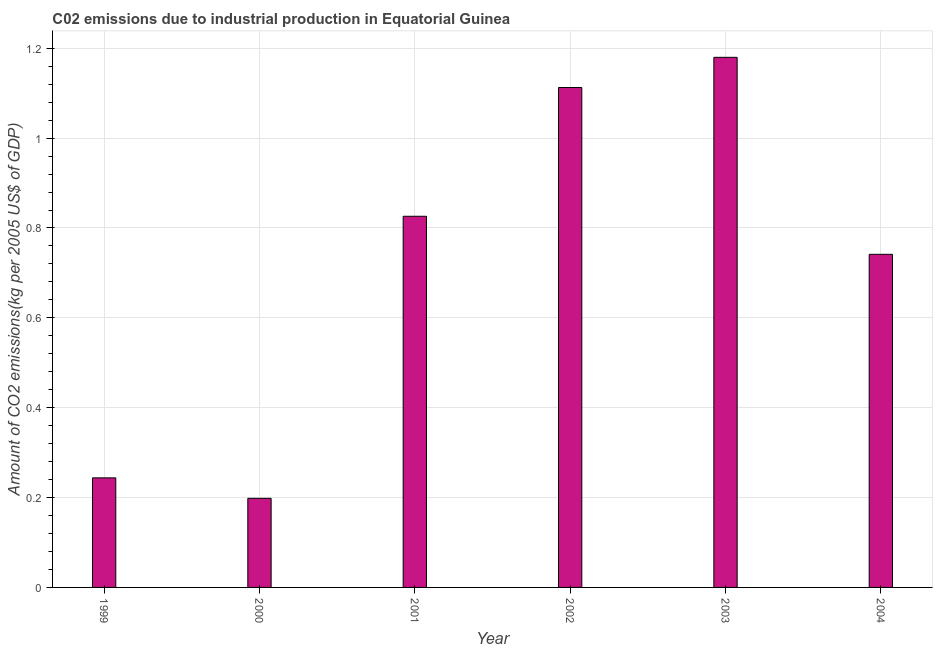Does the graph contain any zero values?
Your answer should be compact. No. What is the title of the graph?
Provide a succinct answer. C02 emissions due to industrial production in Equatorial Guinea. What is the label or title of the X-axis?
Ensure brevity in your answer.  Year. What is the label or title of the Y-axis?
Give a very brief answer. Amount of CO2 emissions(kg per 2005 US$ of GDP). What is the amount of co2 emissions in 2003?
Give a very brief answer. 1.18. Across all years, what is the maximum amount of co2 emissions?
Offer a very short reply. 1.18. Across all years, what is the minimum amount of co2 emissions?
Your answer should be compact. 0.2. In which year was the amount of co2 emissions maximum?
Your response must be concise. 2003. What is the sum of the amount of co2 emissions?
Your answer should be very brief. 4.3. What is the difference between the amount of co2 emissions in 1999 and 2001?
Make the answer very short. -0.58. What is the average amount of co2 emissions per year?
Ensure brevity in your answer.  0.72. What is the median amount of co2 emissions?
Provide a short and direct response. 0.78. What is the ratio of the amount of co2 emissions in 1999 to that in 2002?
Keep it short and to the point. 0.22. Is the amount of co2 emissions in 1999 less than that in 2002?
Provide a succinct answer. Yes. Is the difference between the amount of co2 emissions in 2001 and 2003 greater than the difference between any two years?
Keep it short and to the point. No. What is the difference between the highest and the second highest amount of co2 emissions?
Offer a terse response. 0.07. Is the sum of the amount of co2 emissions in 1999 and 2003 greater than the maximum amount of co2 emissions across all years?
Your answer should be very brief. Yes. Are all the bars in the graph horizontal?
Make the answer very short. No. What is the Amount of CO2 emissions(kg per 2005 US$ of GDP) of 1999?
Your response must be concise. 0.24. What is the Amount of CO2 emissions(kg per 2005 US$ of GDP) in 2000?
Keep it short and to the point. 0.2. What is the Amount of CO2 emissions(kg per 2005 US$ of GDP) in 2001?
Your answer should be very brief. 0.83. What is the Amount of CO2 emissions(kg per 2005 US$ of GDP) in 2002?
Give a very brief answer. 1.11. What is the Amount of CO2 emissions(kg per 2005 US$ of GDP) of 2003?
Keep it short and to the point. 1.18. What is the Amount of CO2 emissions(kg per 2005 US$ of GDP) in 2004?
Provide a short and direct response. 0.74. What is the difference between the Amount of CO2 emissions(kg per 2005 US$ of GDP) in 1999 and 2000?
Your answer should be compact. 0.05. What is the difference between the Amount of CO2 emissions(kg per 2005 US$ of GDP) in 1999 and 2001?
Give a very brief answer. -0.58. What is the difference between the Amount of CO2 emissions(kg per 2005 US$ of GDP) in 1999 and 2002?
Make the answer very short. -0.87. What is the difference between the Amount of CO2 emissions(kg per 2005 US$ of GDP) in 1999 and 2003?
Provide a short and direct response. -0.94. What is the difference between the Amount of CO2 emissions(kg per 2005 US$ of GDP) in 1999 and 2004?
Ensure brevity in your answer.  -0.5. What is the difference between the Amount of CO2 emissions(kg per 2005 US$ of GDP) in 2000 and 2001?
Your response must be concise. -0.63. What is the difference between the Amount of CO2 emissions(kg per 2005 US$ of GDP) in 2000 and 2002?
Give a very brief answer. -0.91. What is the difference between the Amount of CO2 emissions(kg per 2005 US$ of GDP) in 2000 and 2003?
Offer a very short reply. -0.98. What is the difference between the Amount of CO2 emissions(kg per 2005 US$ of GDP) in 2000 and 2004?
Offer a very short reply. -0.54. What is the difference between the Amount of CO2 emissions(kg per 2005 US$ of GDP) in 2001 and 2002?
Give a very brief answer. -0.29. What is the difference between the Amount of CO2 emissions(kg per 2005 US$ of GDP) in 2001 and 2003?
Your answer should be compact. -0.35. What is the difference between the Amount of CO2 emissions(kg per 2005 US$ of GDP) in 2001 and 2004?
Keep it short and to the point. 0.08. What is the difference between the Amount of CO2 emissions(kg per 2005 US$ of GDP) in 2002 and 2003?
Ensure brevity in your answer.  -0.07. What is the difference between the Amount of CO2 emissions(kg per 2005 US$ of GDP) in 2002 and 2004?
Your response must be concise. 0.37. What is the difference between the Amount of CO2 emissions(kg per 2005 US$ of GDP) in 2003 and 2004?
Your answer should be very brief. 0.44. What is the ratio of the Amount of CO2 emissions(kg per 2005 US$ of GDP) in 1999 to that in 2000?
Make the answer very short. 1.23. What is the ratio of the Amount of CO2 emissions(kg per 2005 US$ of GDP) in 1999 to that in 2001?
Your response must be concise. 0.29. What is the ratio of the Amount of CO2 emissions(kg per 2005 US$ of GDP) in 1999 to that in 2002?
Offer a terse response. 0.22. What is the ratio of the Amount of CO2 emissions(kg per 2005 US$ of GDP) in 1999 to that in 2003?
Keep it short and to the point. 0.21. What is the ratio of the Amount of CO2 emissions(kg per 2005 US$ of GDP) in 1999 to that in 2004?
Ensure brevity in your answer.  0.33. What is the ratio of the Amount of CO2 emissions(kg per 2005 US$ of GDP) in 2000 to that in 2001?
Your response must be concise. 0.24. What is the ratio of the Amount of CO2 emissions(kg per 2005 US$ of GDP) in 2000 to that in 2002?
Your answer should be very brief. 0.18. What is the ratio of the Amount of CO2 emissions(kg per 2005 US$ of GDP) in 2000 to that in 2003?
Keep it short and to the point. 0.17. What is the ratio of the Amount of CO2 emissions(kg per 2005 US$ of GDP) in 2000 to that in 2004?
Your answer should be very brief. 0.27. What is the ratio of the Amount of CO2 emissions(kg per 2005 US$ of GDP) in 2001 to that in 2002?
Make the answer very short. 0.74. What is the ratio of the Amount of CO2 emissions(kg per 2005 US$ of GDP) in 2001 to that in 2003?
Give a very brief answer. 0.7. What is the ratio of the Amount of CO2 emissions(kg per 2005 US$ of GDP) in 2001 to that in 2004?
Your answer should be very brief. 1.11. What is the ratio of the Amount of CO2 emissions(kg per 2005 US$ of GDP) in 2002 to that in 2003?
Your answer should be compact. 0.94. What is the ratio of the Amount of CO2 emissions(kg per 2005 US$ of GDP) in 2002 to that in 2004?
Provide a succinct answer. 1.5. What is the ratio of the Amount of CO2 emissions(kg per 2005 US$ of GDP) in 2003 to that in 2004?
Offer a terse response. 1.59. 